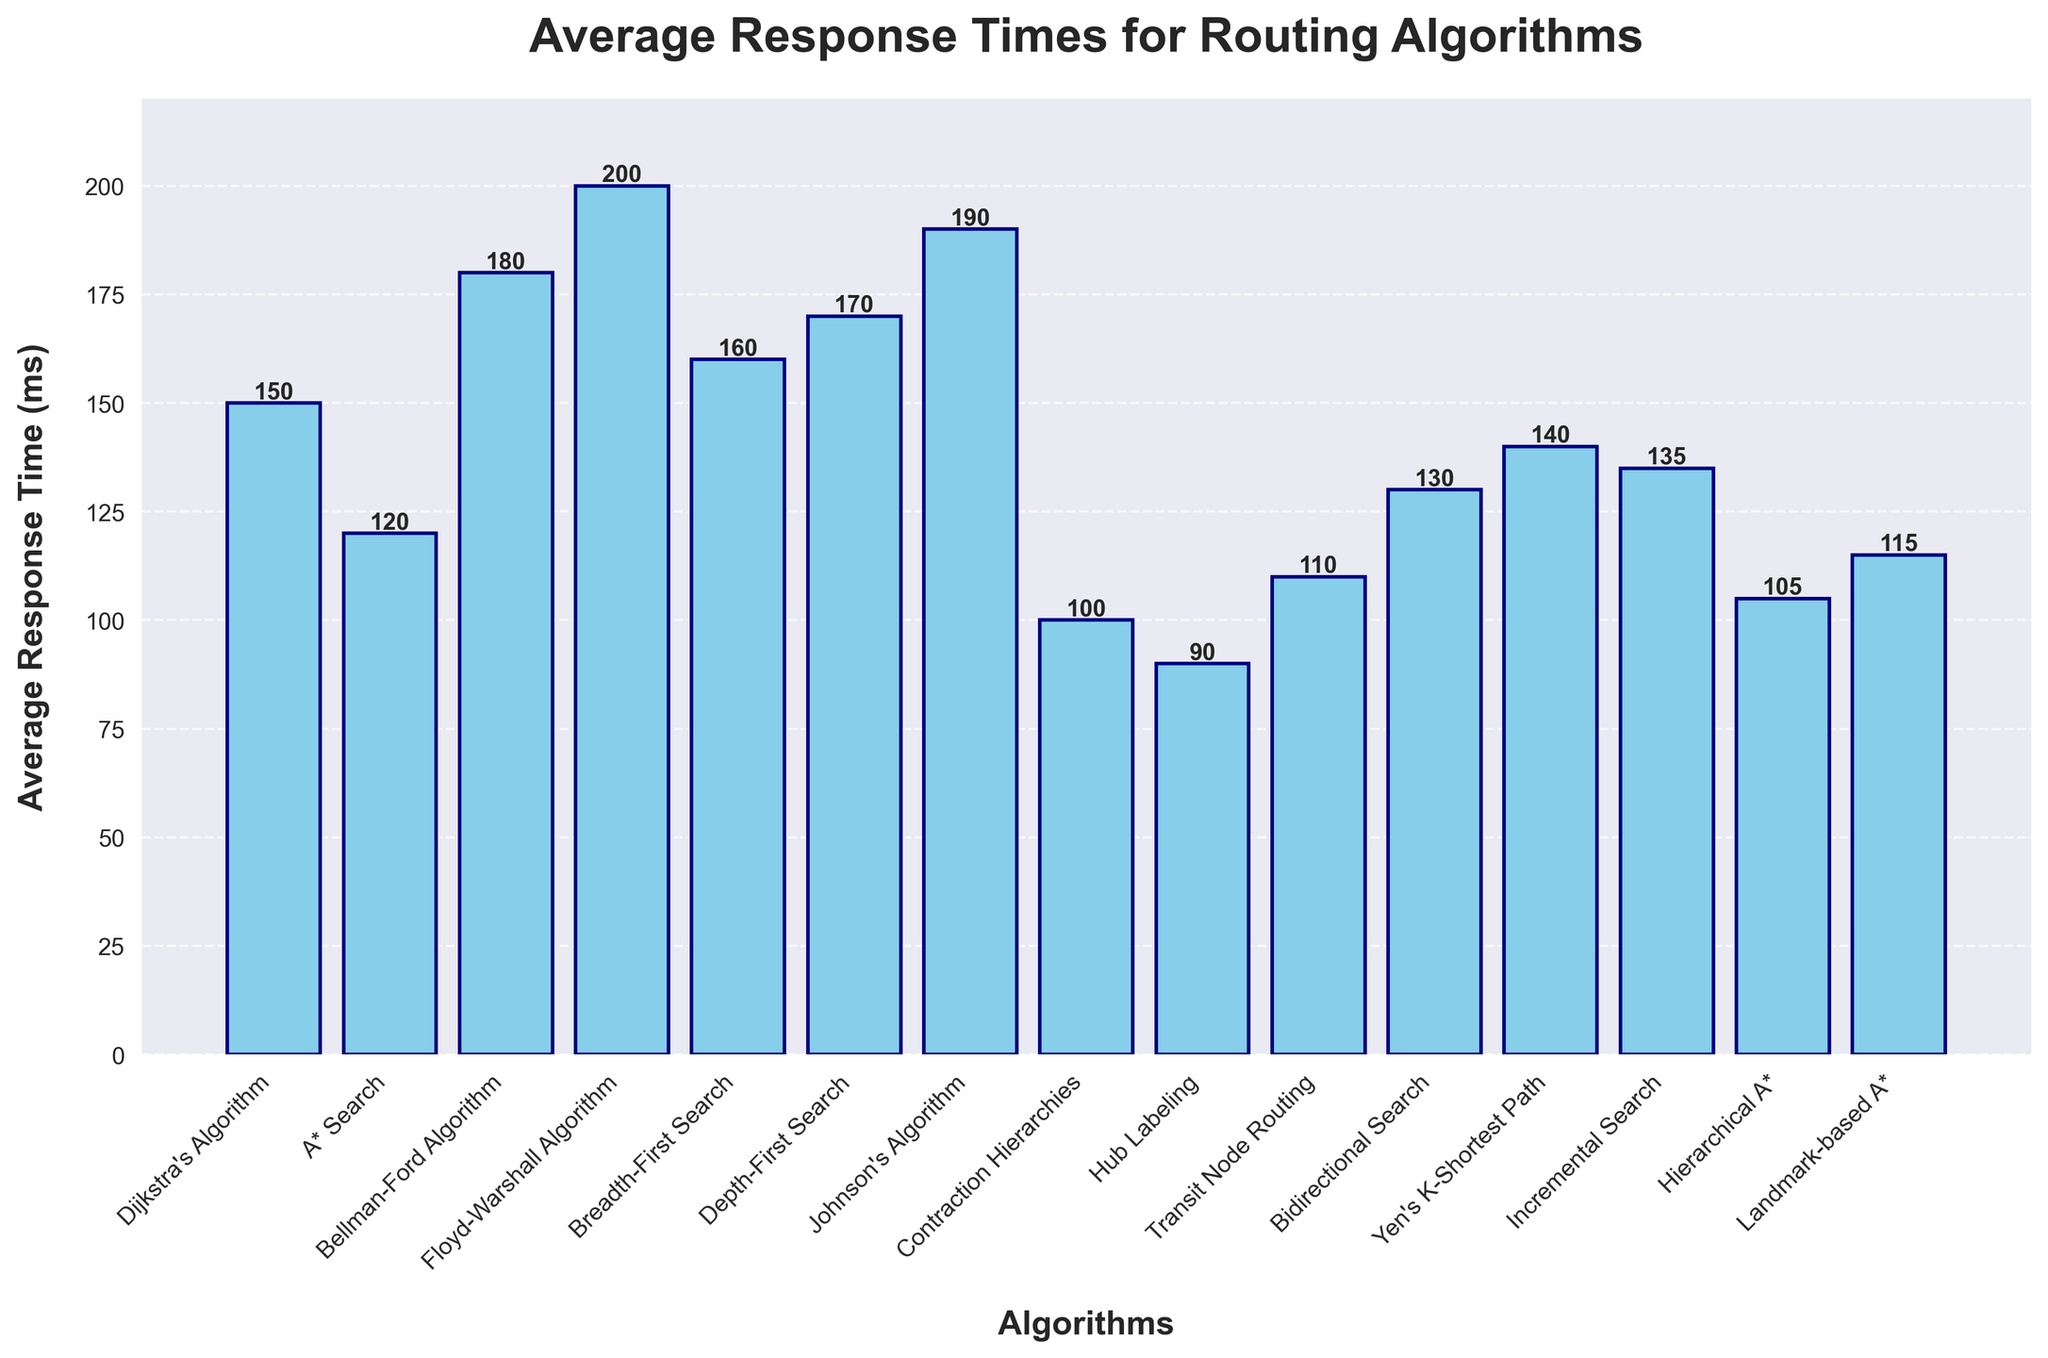Which algorithm has the lowest average response time? The bar for Hub Labeling is the shortest, indicating it has the lowest average response time.
Answer: Hub Labeling Which algorithm has the highest average response time? The bar for Floyd-Warshall Algorithm is the tallest, indicating it has the highest average response time.
Answer: Floyd-Warshall Algorithm How does the average response time of A* Search compare to Dijkstra's Algorithm? The bar for A* Search is shorter than the bar for Dijkstra's Algorithm, indicating A* Search has a lower average response time.
Answer: A* Search has a lower average response time than Dijkstra's Algorithm What is the difference in average response time between Floyd-Warshall Algorithm and Hub Labeling? The average response time for Floyd-Warshall Algorithm is 200 ms while for Hub Labeling it is 90 ms. The difference is 200 - 90.
Answer: 110 ms Which algorithms have an average response time under 110 ms? The bars for Hub Labeling, Contraction Hierarchies, Hierarchical A*, and Transit Node Routing are all under the 110 ms mark.
Answer: Hub Labeling, Contraction Hierarchies, Hierarchical A*, Transit Node Routing What is the median average response time of the algorithms listed? There are 15 algorithms listed. Ordering the response times: [90, 100, 105, 110, 115, 120, 130, 135, 140, 150, 160, 170, 180, 190, 200]. The median value is the 8th value.
Answer: 135 ms How many algorithms have an average response time greater than 150 ms? By counting, Breadth-First Search, Depth-First Search, Bellman-Ford Algorithm, Johnson's Algorithm, and Floyd-Warshall Algorithm all have times greater than 150 ms.
Answer: 5 What is the total average response time of all algorithms combined? Summing up all the average response times: 150 + 120 + 180 + 200 + 160 + 170 + 190 + 100 + 90 + 110 + 130 + 140 + 135 + 105 + 115 = 2195 ms.
Answer: 2195 ms Which algorithm has an average response time closest to the overall average? The average response time for all algorithms combined is 2195 / 15 = 146.33 ms. The closest value is Yen's K-Shortest Path with 140 ms.
Answer: Yen's K-Shortest Path Is the average response time of Bidirectional Search higher or lower than that of Incremental Search? Observing the bars, Bidirectional Search is shorter than Incremental Search.
Answer: Lower 